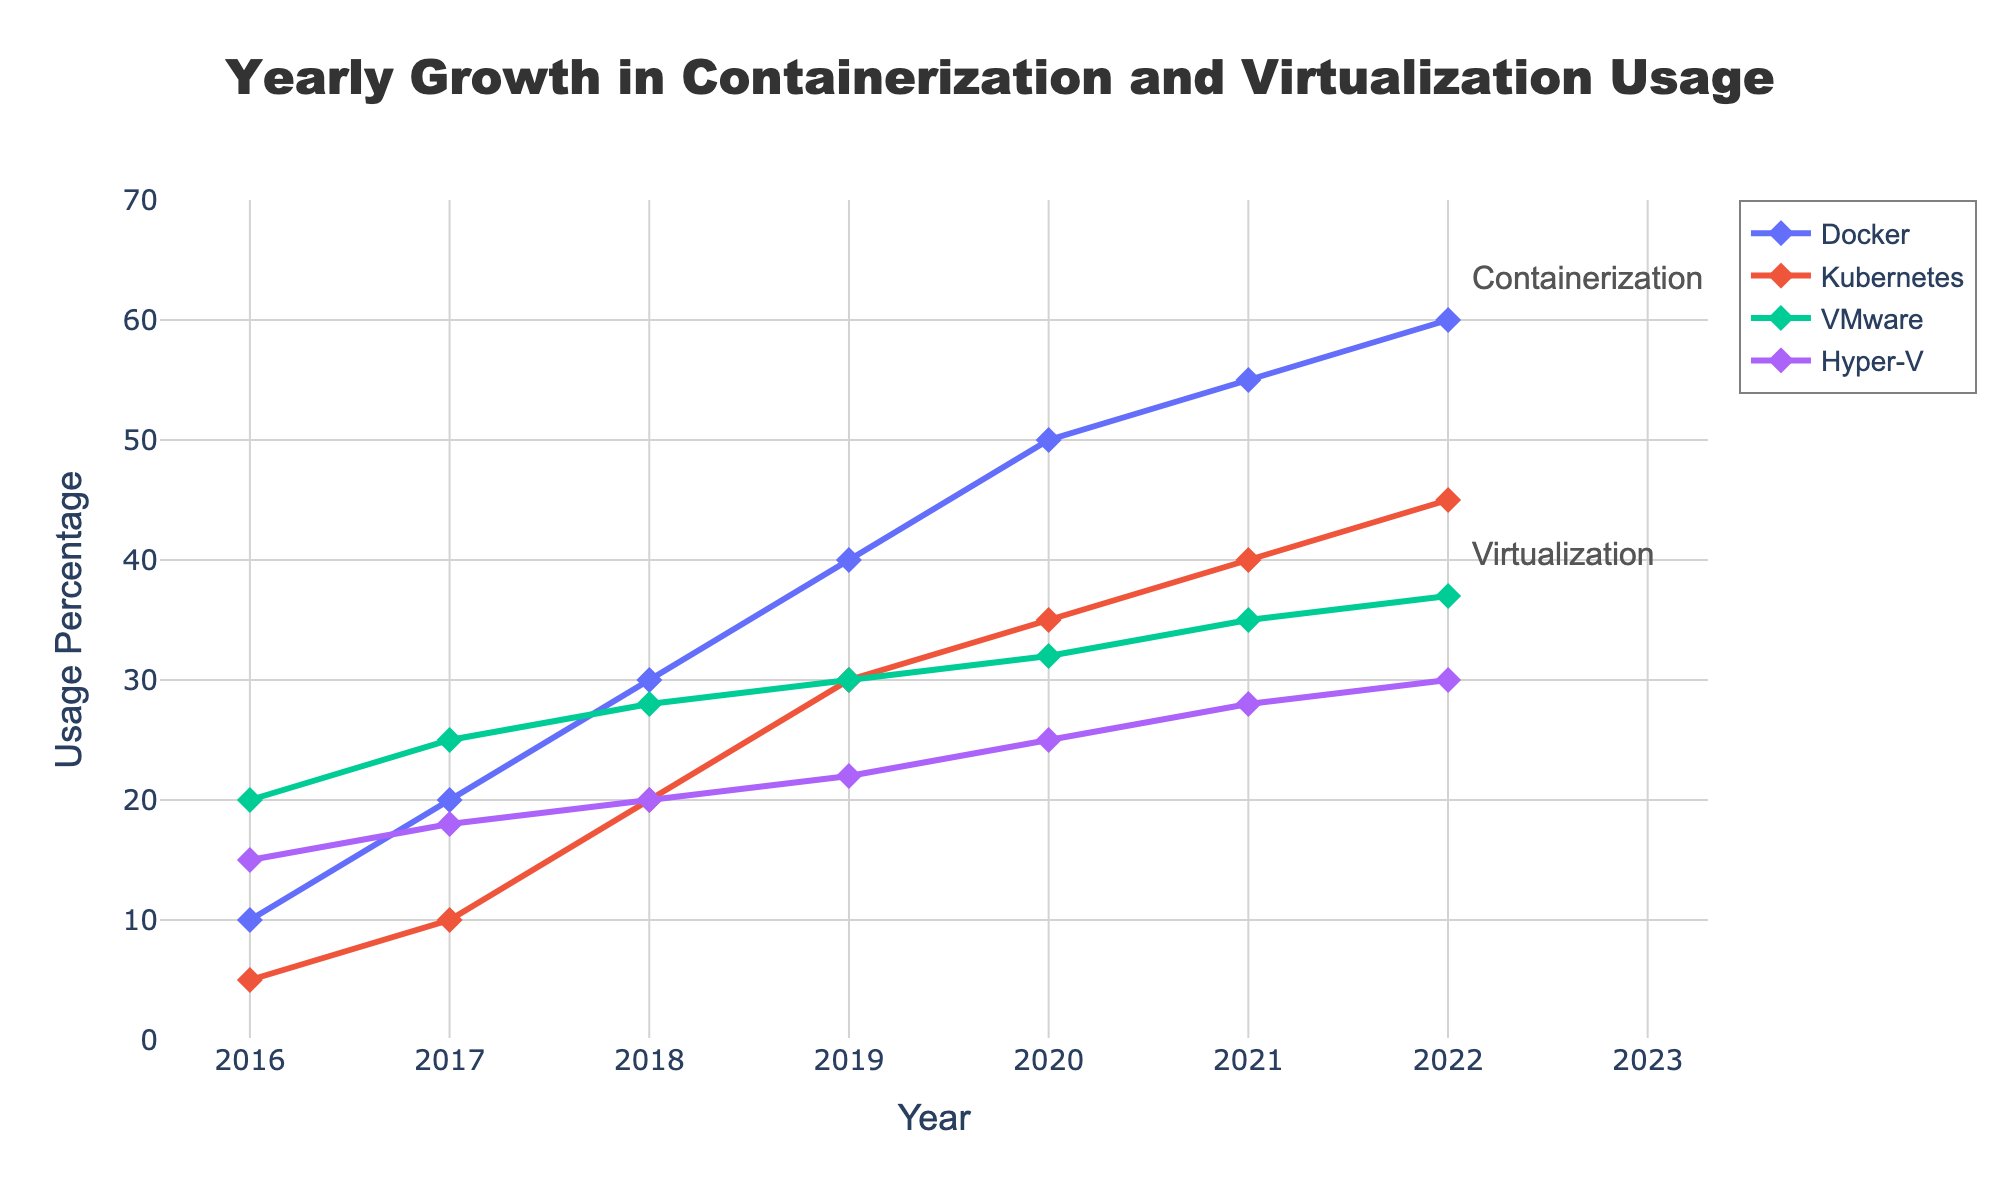what is the title of the plot? The title is located at the top center of the plot. It should be explicit about the content and scope of the plot.
Answer: Yearly Growth in Containerization and Virtualization Usage what years are covered in the plot? The x-axis represents the years covered in the analysis. By observing the axis labels, one can determine the range of years.
Answer: 2016-2022 which technology had the highest usage percentage in 2022? The plot shows multiple technologies with their respective usage percentages for each year. By looking at the data points for 2022, you can identify the highest one.
Answer: Docker how did the usage percentage of Kubernetes change from 2016 to 2022? The plot has lines representing the usage percentage changes over time. By examining the starting and ending points for Kubernetes from 2016 to 2022, one can see the growth. Kubernetes starts at 5% in 2016 and ends at 45% in 2022.
Answer: Increased by 40% which virtualization technology had a slower growth rate, VMware or Hyper-V? By comparing the slopes of the lines for VMware and Hyper-V over the given timeframe, you can determine which one had a slower rate of growth. VMware starts at 20% in 2016 and ends at 37% in 2022, while Hyper-V starts at 15% and ends at 30%. The growth rate can be deduced from the increments.
Answer: Hyper-V compare the growth trends of containerization vs virtualization over the years By comparing the average slopes and patterns of the lines for containerization technologies (Docker and Kubernetes) against virtualization technologies (VMware and Hyper-V), general trends of growth can be deduced. In general, containerization shows steeper slopes indicating rapid growth, whereas virtualization shows slower growth patterns.
Answer: Containerization grew faster than virtualization what was the average usage percentage of VMware across all years? To find the average usage percentage of VMware, sum the percentages from each year and divide by the number of years. (20+25+28+30+32+35+37)/7 = 207/7 = 29.57
Answer: 29.57 how much higher was Docker's usage percentage in 2022 compared to its usage in 2016? Examine the plot to find Docker's usage percentages in 2016 and 2022. Subtract the 2016 value from the 2022 value to get the difference. Docker was at 10% in 2016 and 60% in 2022. The difference is 60% - 10%.
Answer: 50% did any technology's usage percentage decrease over the years? By examining the lines for each technology in the plot, one can determine if any line shows a downward trend from left to right. None of the technologies show a decline.
Answer: No what was the total usage percentage for all technologies in 2020? Sum the data points for each technology for the year 2020. The values are: Docker (50%), Kubernetes (35%), VMware (32%), and Hyper-V (25%). The total is 50+35+32+25 = 142.
Answer: 142 